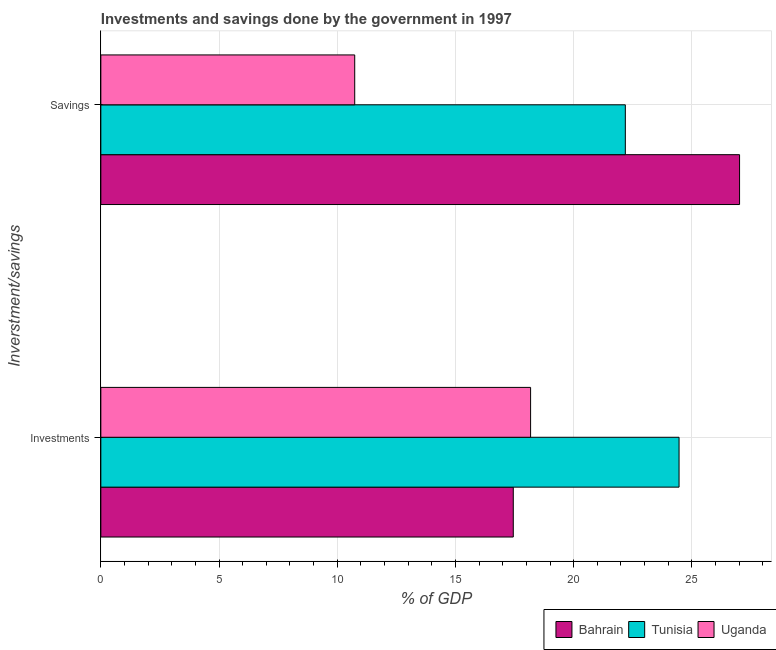How many groups of bars are there?
Offer a terse response. 2. Are the number of bars per tick equal to the number of legend labels?
Provide a succinct answer. Yes. Are the number of bars on each tick of the Y-axis equal?
Ensure brevity in your answer.  Yes. What is the label of the 2nd group of bars from the top?
Offer a terse response. Investments. What is the savings of government in Uganda?
Offer a terse response. 10.74. Across all countries, what is the maximum savings of government?
Your answer should be very brief. 27.02. Across all countries, what is the minimum savings of government?
Offer a very short reply. 10.74. In which country was the savings of government maximum?
Your answer should be compact. Bahrain. In which country was the investments of government minimum?
Give a very brief answer. Bahrain. What is the total investments of government in the graph?
Provide a short and direct response. 60.08. What is the difference between the investments of government in Tunisia and that in Uganda?
Offer a very short reply. 6.28. What is the difference between the savings of government in Bahrain and the investments of government in Tunisia?
Offer a terse response. 2.56. What is the average savings of government per country?
Your answer should be very brief. 19.98. What is the difference between the savings of government and investments of government in Bahrain?
Your answer should be very brief. 9.57. In how many countries, is the savings of government greater than 26 %?
Give a very brief answer. 1. What is the ratio of the savings of government in Tunisia to that in Uganda?
Offer a terse response. 2.07. Is the investments of government in Bahrain less than that in Uganda?
Provide a succinct answer. Yes. What does the 1st bar from the top in Savings represents?
Provide a succinct answer. Uganda. What does the 3rd bar from the bottom in Savings represents?
Provide a short and direct response. Uganda. How many bars are there?
Provide a short and direct response. 6. Are all the bars in the graph horizontal?
Your answer should be compact. Yes. Are the values on the major ticks of X-axis written in scientific E-notation?
Ensure brevity in your answer.  No. Does the graph contain grids?
Your answer should be compact. Yes. How many legend labels are there?
Your answer should be compact. 3. How are the legend labels stacked?
Your answer should be very brief. Horizontal. What is the title of the graph?
Provide a short and direct response. Investments and savings done by the government in 1997. Does "Singapore" appear as one of the legend labels in the graph?
Make the answer very short. No. What is the label or title of the X-axis?
Provide a short and direct response. % of GDP. What is the label or title of the Y-axis?
Your answer should be compact. Inverstment/savings. What is the % of GDP in Bahrain in Investments?
Give a very brief answer. 17.45. What is the % of GDP of Tunisia in Investments?
Your answer should be compact. 24.46. What is the % of GDP in Uganda in Investments?
Provide a short and direct response. 18.18. What is the % of GDP in Bahrain in Savings?
Make the answer very short. 27.02. What is the % of GDP of Tunisia in Savings?
Give a very brief answer. 22.19. What is the % of GDP in Uganda in Savings?
Provide a short and direct response. 10.74. Across all Inverstment/savings, what is the maximum % of GDP in Bahrain?
Offer a very short reply. 27.02. Across all Inverstment/savings, what is the maximum % of GDP of Tunisia?
Make the answer very short. 24.46. Across all Inverstment/savings, what is the maximum % of GDP of Uganda?
Your answer should be compact. 18.18. Across all Inverstment/savings, what is the minimum % of GDP in Bahrain?
Keep it short and to the point. 17.45. Across all Inverstment/savings, what is the minimum % of GDP of Tunisia?
Offer a terse response. 22.19. Across all Inverstment/savings, what is the minimum % of GDP of Uganda?
Offer a very short reply. 10.74. What is the total % of GDP of Bahrain in the graph?
Your answer should be very brief. 44.46. What is the total % of GDP in Tunisia in the graph?
Keep it short and to the point. 46.65. What is the total % of GDP of Uganda in the graph?
Your answer should be compact. 28.92. What is the difference between the % of GDP in Bahrain in Investments and that in Savings?
Give a very brief answer. -9.57. What is the difference between the % of GDP of Tunisia in Investments and that in Savings?
Make the answer very short. 2.27. What is the difference between the % of GDP of Uganda in Investments and that in Savings?
Keep it short and to the point. 7.44. What is the difference between the % of GDP in Bahrain in Investments and the % of GDP in Tunisia in Savings?
Keep it short and to the point. -4.74. What is the difference between the % of GDP in Bahrain in Investments and the % of GDP in Uganda in Savings?
Ensure brevity in your answer.  6.71. What is the difference between the % of GDP of Tunisia in Investments and the % of GDP of Uganda in Savings?
Give a very brief answer. 13.72. What is the average % of GDP in Bahrain per Inverstment/savings?
Offer a very short reply. 22.23. What is the average % of GDP in Tunisia per Inverstment/savings?
Give a very brief answer. 23.32. What is the average % of GDP of Uganda per Inverstment/savings?
Ensure brevity in your answer.  14.46. What is the difference between the % of GDP of Bahrain and % of GDP of Tunisia in Investments?
Your response must be concise. -7.01. What is the difference between the % of GDP of Bahrain and % of GDP of Uganda in Investments?
Your answer should be very brief. -0.73. What is the difference between the % of GDP in Tunisia and % of GDP in Uganda in Investments?
Your answer should be very brief. 6.28. What is the difference between the % of GDP of Bahrain and % of GDP of Tunisia in Savings?
Your answer should be compact. 4.83. What is the difference between the % of GDP of Bahrain and % of GDP of Uganda in Savings?
Your response must be concise. 16.28. What is the difference between the % of GDP of Tunisia and % of GDP of Uganda in Savings?
Your response must be concise. 11.45. What is the ratio of the % of GDP in Bahrain in Investments to that in Savings?
Offer a terse response. 0.65. What is the ratio of the % of GDP of Tunisia in Investments to that in Savings?
Your answer should be very brief. 1.1. What is the ratio of the % of GDP of Uganda in Investments to that in Savings?
Offer a terse response. 1.69. What is the difference between the highest and the second highest % of GDP in Bahrain?
Your response must be concise. 9.57. What is the difference between the highest and the second highest % of GDP of Tunisia?
Make the answer very short. 2.27. What is the difference between the highest and the second highest % of GDP of Uganda?
Your response must be concise. 7.44. What is the difference between the highest and the lowest % of GDP in Bahrain?
Offer a terse response. 9.57. What is the difference between the highest and the lowest % of GDP in Tunisia?
Offer a terse response. 2.27. What is the difference between the highest and the lowest % of GDP in Uganda?
Offer a terse response. 7.44. 